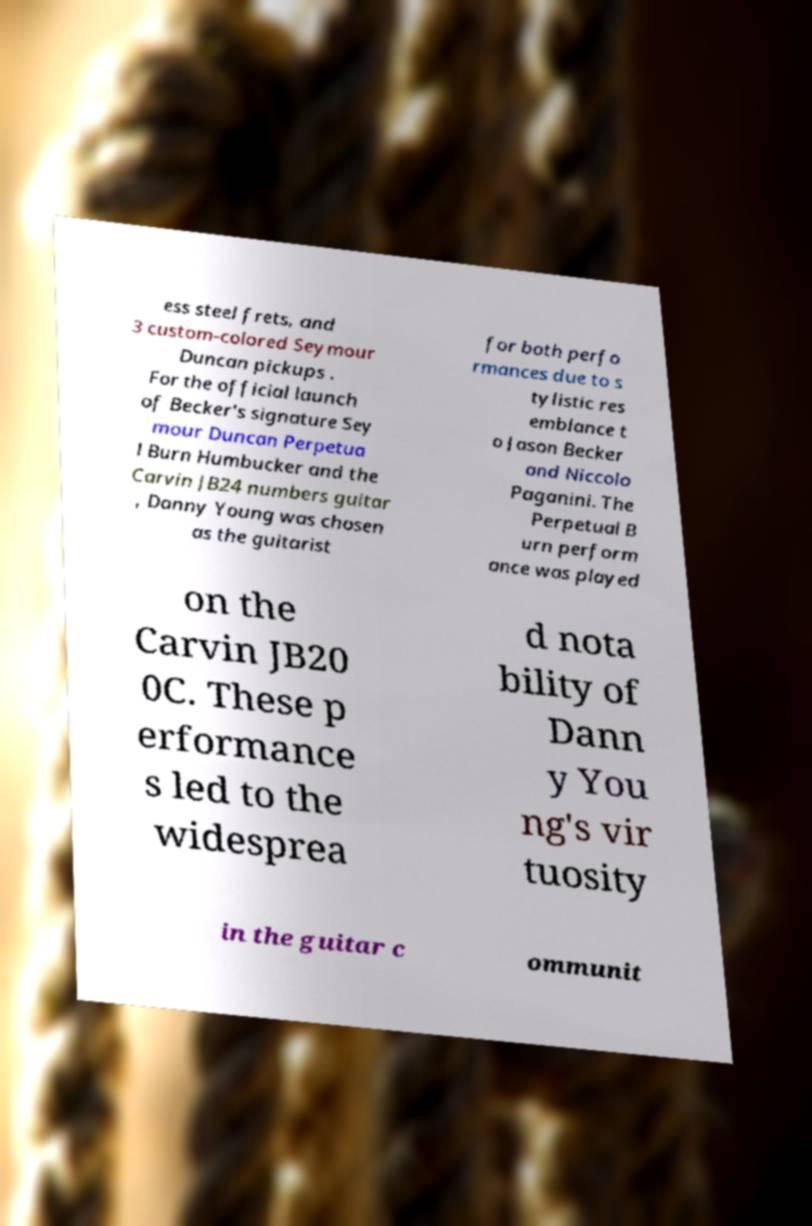Please read and relay the text visible in this image. What does it say? ess steel frets, and 3 custom-colored Seymour Duncan pickups . For the official launch of Becker's signature Sey mour Duncan Perpetua l Burn Humbucker and the Carvin JB24 numbers guitar , Danny Young was chosen as the guitarist for both perfo rmances due to s tylistic res emblance t o Jason Becker and Niccolo Paganini. The Perpetual B urn perform ance was played on the Carvin JB20 0C. These p erformance s led to the widesprea d nota bility of Dann y You ng's vir tuosity in the guitar c ommunit 